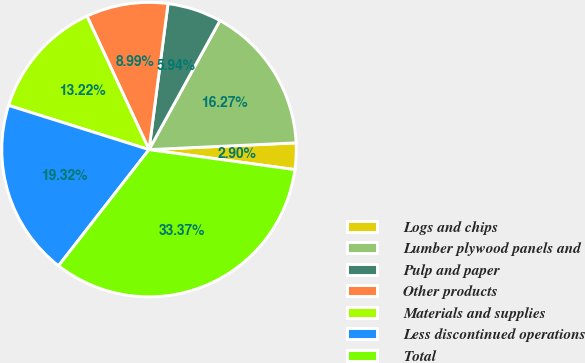Convert chart to OTSL. <chart><loc_0><loc_0><loc_500><loc_500><pie_chart><fcel>Logs and chips<fcel>Lumber plywood panels and<fcel>Pulp and paper<fcel>Other products<fcel>Materials and supplies<fcel>Less discontinued operations<fcel>Total<nl><fcel>2.9%<fcel>16.27%<fcel>5.94%<fcel>8.99%<fcel>13.22%<fcel>19.32%<fcel>33.37%<nl></chart> 